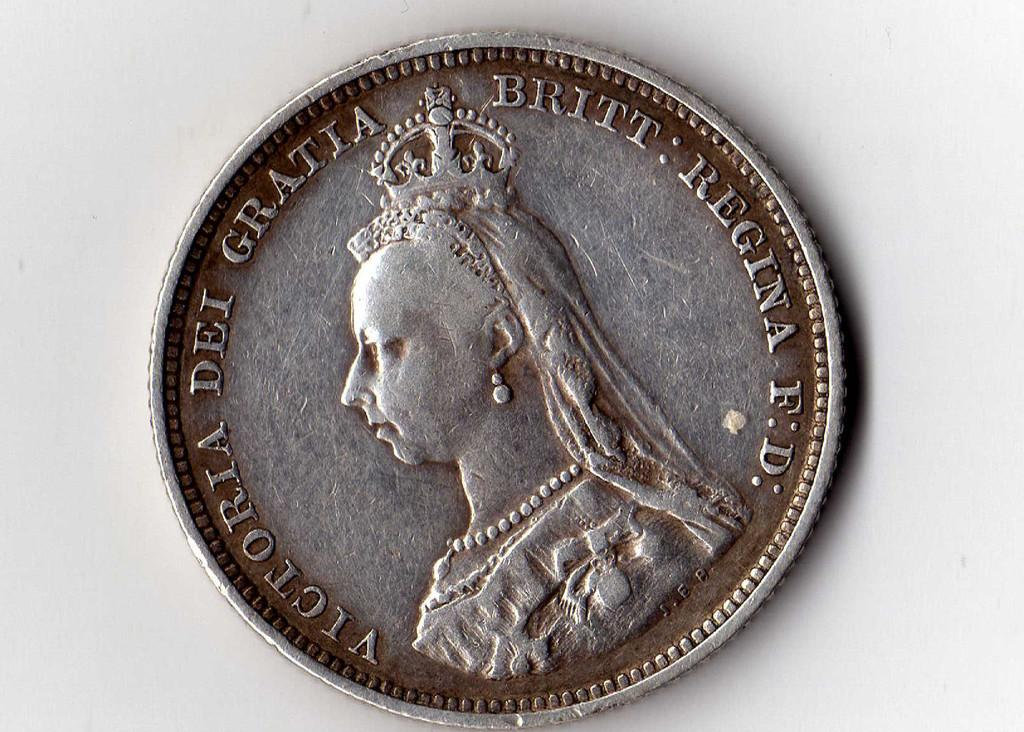What object is the main focus of the image? There is a coin in the image. What can be found on the surface of the coin? There is text on the coin. What can be seen in the background of the image? The background of the image features a plane. What type of beam is holding up the grandfather in the image? There is no beam or grandfather present in the image; it only features a coin with text and a background with a plane. 